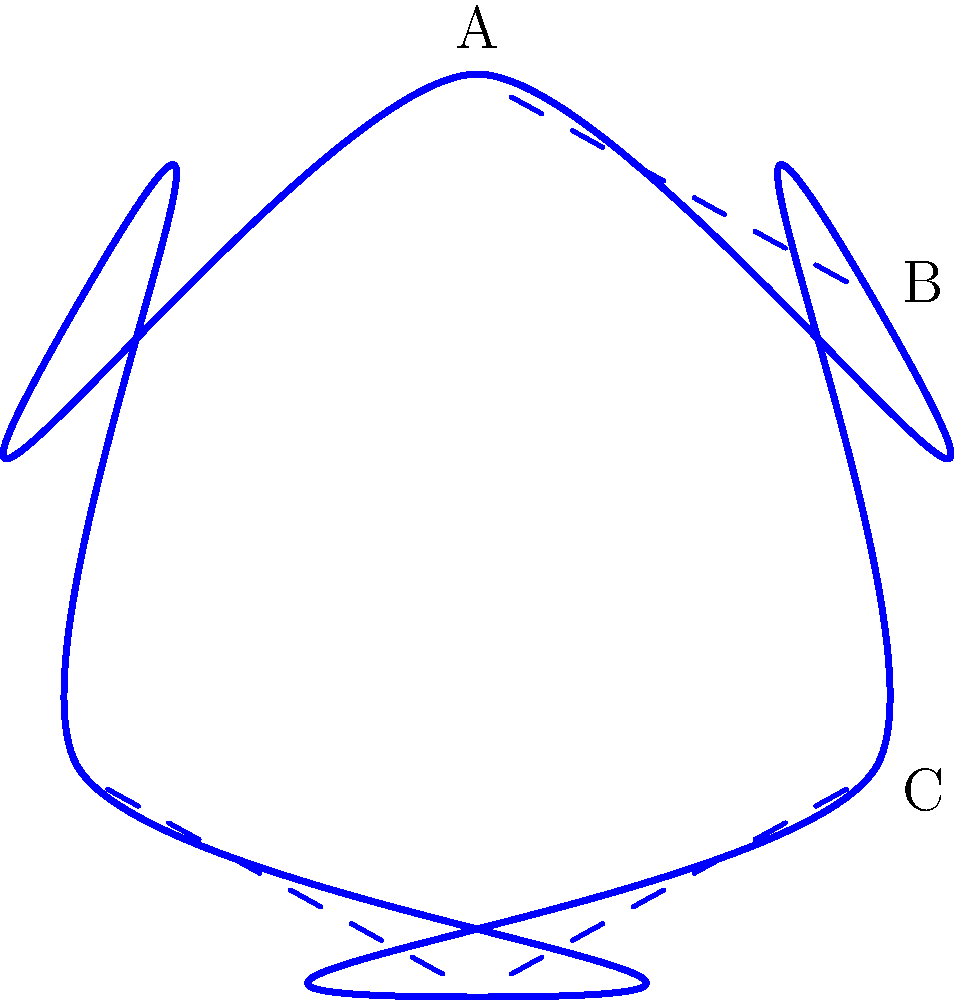Consider the knot diagram shown above, which represents a trefoil knot. What is the unknotting number of this knot, and how does this relate to its classification as a prime knot? To answer this question, let's follow these steps:

1) First, let's define the unknotting number:
   The unknotting number of a knot is the minimum number of crossing changes required to transform the knot into an unknot (trivial knot).

2) For the trefoil knot:
   - It has three crossings in its minimal diagram (as shown in the figure).
   - Changing any one of these crossings will result in an unknot.

3) Therefore, the unknotting number of the trefoil knot is 1.

4) Now, let's consider what this means for its classification as a prime knot:
   - A prime knot is a knot that cannot be decomposed into two simpler nontrivial knots.
   - The fact that the trefoil has an unknotting number of 1 supports its classification as a prime knot.

5) Here's why:
   - If the trefoil were composite (not prime), it would require at least two crossing changes to unknot it completely.
   - This is because each component of a composite knot would need at least one crossing change.

6) The trefoil's unknotting number of 1 indicates that it cannot be decomposed into simpler nontrivial knots, confirming its status as a prime knot.

7) Additionally, the trefoil knot is the simplest non-trivial knot, which further supports its classification as prime.

Therefore, the unknotting number of 1 for the trefoil knot is consistent with and supports its classification as a prime knot.
Answer: Unknotting number: 1; Supports prime classification 